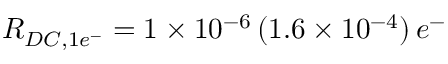Convert formula to latex. <formula><loc_0><loc_0><loc_500><loc_500>R _ { D C , 1 e ^ { - } } = 1 \times 1 0 ^ { - 6 } \, ( 1 . 6 \times 1 0 ^ { - 4 } ) \, e ^ { - }</formula> 